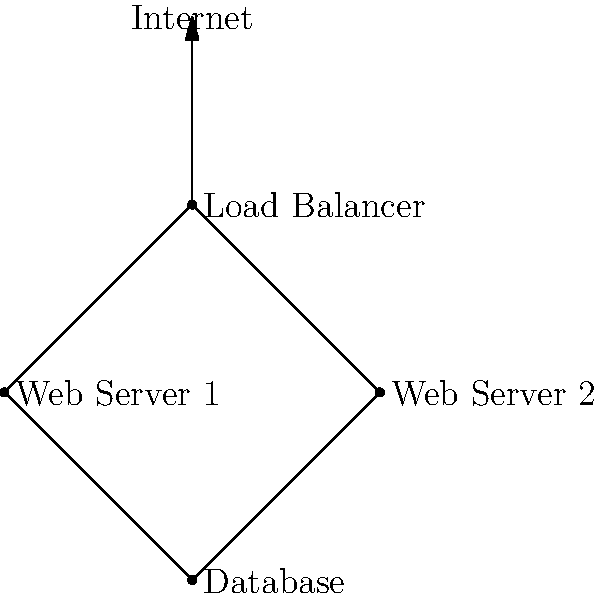In the network topology diagram for the online platform's infrastructure, what component ensures even distribution of incoming traffic and provides redundancy for the web servers? To answer this question, let's analyze the components of the network topology diagram:

1. The diagram shows a hierarchical structure with multiple components.
2. At the top, we see a connection from the Internet to a central node.
3. This central node is labeled "Load Balancer".
4. The Load Balancer is connected to two nodes labeled "Web Server 1" and "Web Server 2".
5. Both web servers are connected to a single "Database" node at the bottom.

The Load Balancer plays a crucial role in this topology:

1. It sits between the Internet and the web servers, acting as the entry point for incoming traffic.
2. Its primary function is to distribute incoming requests evenly across multiple web servers.
3. This distribution ensures that no single server becomes overwhelmed with traffic.
4. By having two web servers connected to the Load Balancer, the system provides redundancy.
5. If one web server fails, the Load Balancer can redirect all traffic to the remaining functional server.

Therefore, the Load Balancer is the component that ensures even distribution of incoming traffic and provides redundancy for the web servers in this network topology.
Answer: Load Balancer 